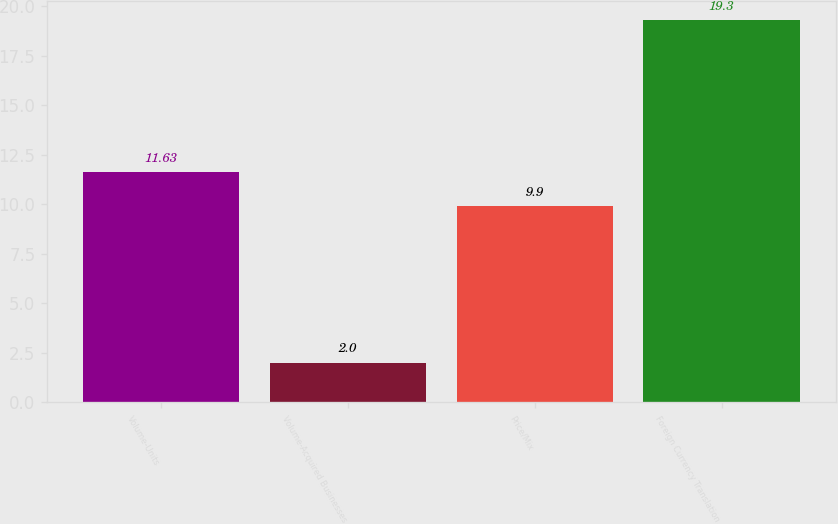Convert chart to OTSL. <chart><loc_0><loc_0><loc_500><loc_500><bar_chart><fcel>Volume-Units<fcel>Volume-Acquired Businesses<fcel>Price/Mix<fcel>Foreign Currency Translation<nl><fcel>11.63<fcel>2<fcel>9.9<fcel>19.3<nl></chart> 